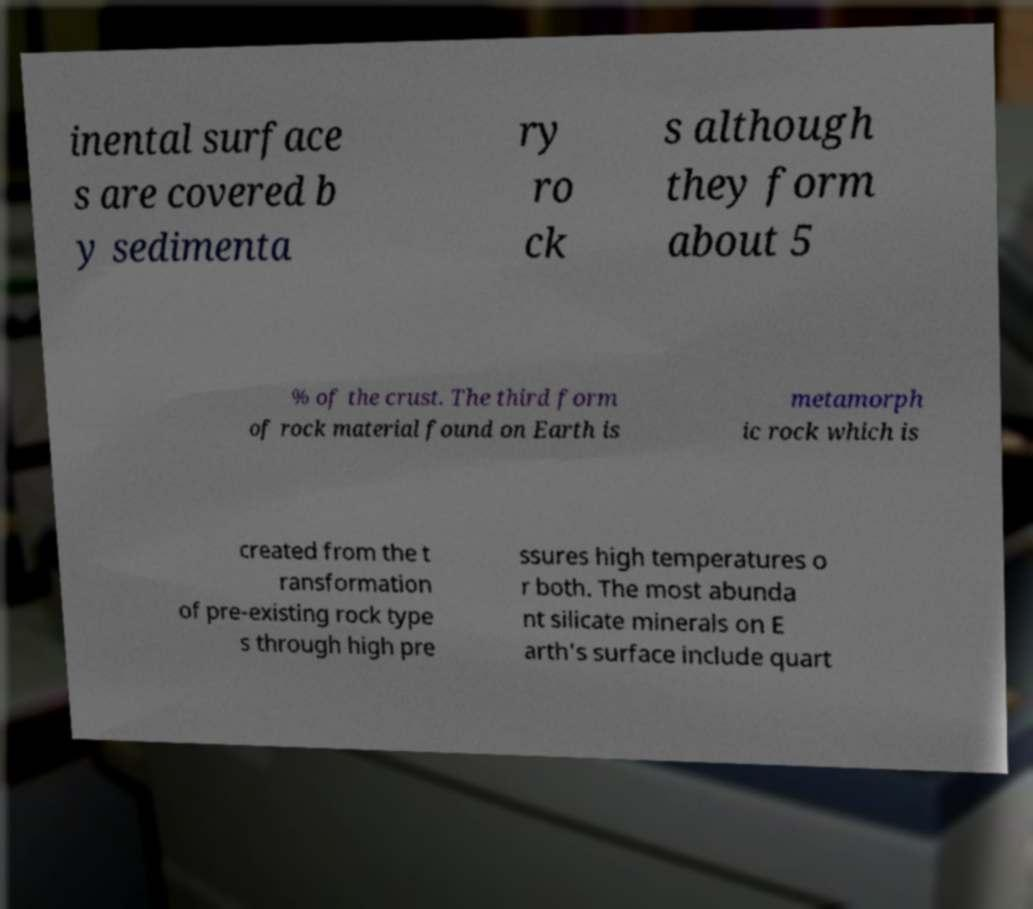Can you read and provide the text displayed in the image?This photo seems to have some interesting text. Can you extract and type it out for me? inental surface s are covered b y sedimenta ry ro ck s although they form about 5 % of the crust. The third form of rock material found on Earth is metamorph ic rock which is created from the t ransformation of pre-existing rock type s through high pre ssures high temperatures o r both. The most abunda nt silicate minerals on E arth's surface include quart 